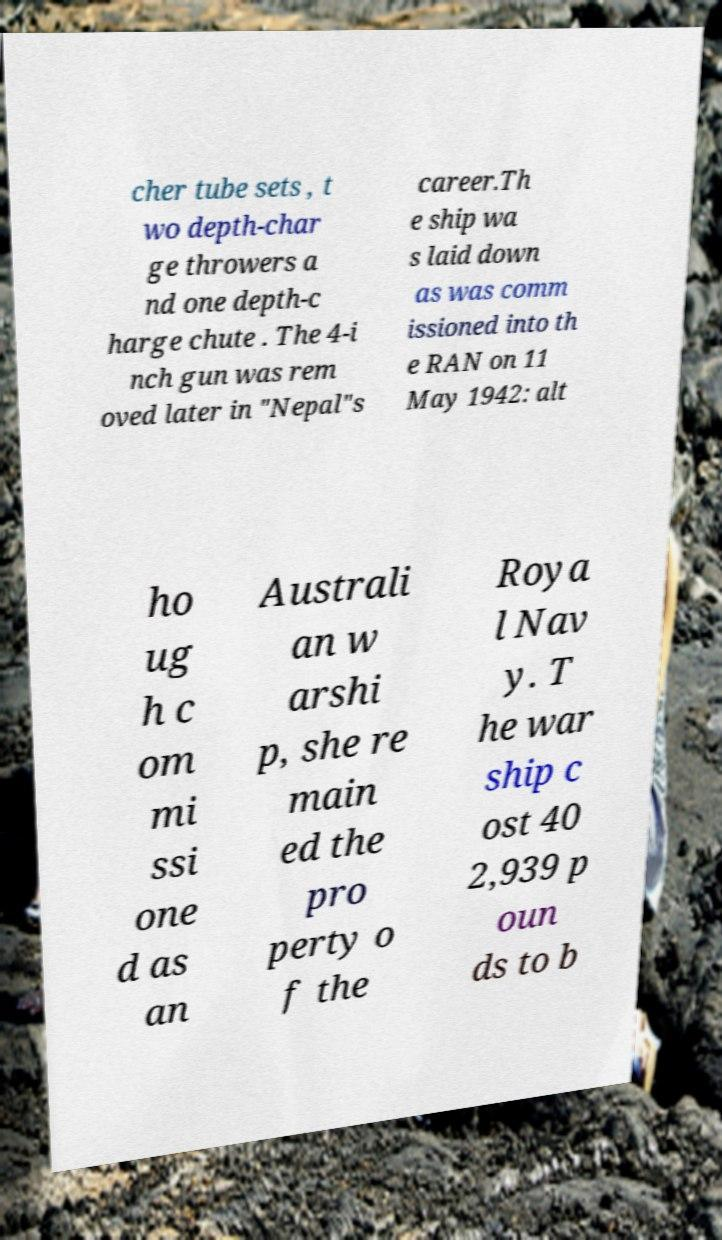Could you extract and type out the text from this image? cher tube sets , t wo depth-char ge throwers a nd one depth-c harge chute . The 4-i nch gun was rem oved later in "Nepal"s career.Th e ship wa s laid down as was comm issioned into th e RAN on 11 May 1942: alt ho ug h c om mi ssi one d as an Australi an w arshi p, she re main ed the pro perty o f the Roya l Nav y. T he war ship c ost 40 2,939 p oun ds to b 